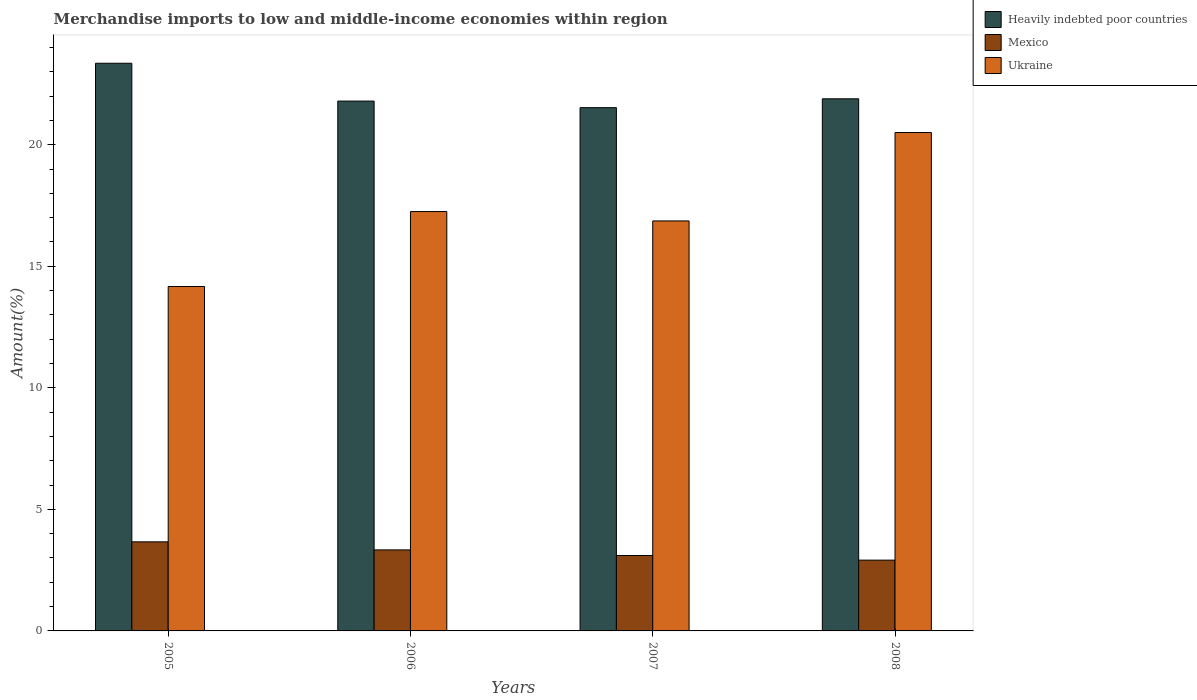How many groups of bars are there?
Provide a succinct answer. 4. Are the number of bars per tick equal to the number of legend labels?
Offer a terse response. Yes. How many bars are there on the 2nd tick from the left?
Your answer should be compact. 3. How many bars are there on the 4th tick from the right?
Keep it short and to the point. 3. In how many cases, is the number of bars for a given year not equal to the number of legend labels?
Your answer should be compact. 0. What is the percentage of amount earned from merchandise imports in Mexico in 2008?
Give a very brief answer. 2.91. Across all years, what is the maximum percentage of amount earned from merchandise imports in Heavily indebted poor countries?
Give a very brief answer. 23.35. Across all years, what is the minimum percentage of amount earned from merchandise imports in Heavily indebted poor countries?
Your response must be concise. 21.52. In which year was the percentage of amount earned from merchandise imports in Ukraine minimum?
Ensure brevity in your answer.  2005. What is the total percentage of amount earned from merchandise imports in Ukraine in the graph?
Provide a succinct answer. 68.78. What is the difference between the percentage of amount earned from merchandise imports in Mexico in 2005 and that in 2007?
Your response must be concise. 0.56. What is the difference between the percentage of amount earned from merchandise imports in Heavily indebted poor countries in 2007 and the percentage of amount earned from merchandise imports in Ukraine in 2005?
Provide a succinct answer. 7.36. What is the average percentage of amount earned from merchandise imports in Mexico per year?
Make the answer very short. 3.25. In the year 2007, what is the difference between the percentage of amount earned from merchandise imports in Ukraine and percentage of amount earned from merchandise imports in Mexico?
Provide a succinct answer. 13.76. In how many years, is the percentage of amount earned from merchandise imports in Heavily indebted poor countries greater than 21 %?
Provide a succinct answer. 4. What is the ratio of the percentage of amount earned from merchandise imports in Ukraine in 2006 to that in 2008?
Your answer should be compact. 0.84. What is the difference between the highest and the second highest percentage of amount earned from merchandise imports in Heavily indebted poor countries?
Your answer should be compact. 1.46. What is the difference between the highest and the lowest percentage of amount earned from merchandise imports in Heavily indebted poor countries?
Your answer should be compact. 1.83. What does the 1st bar from the left in 2007 represents?
Your answer should be very brief. Heavily indebted poor countries. What does the 3rd bar from the right in 2007 represents?
Keep it short and to the point. Heavily indebted poor countries. How many bars are there?
Ensure brevity in your answer.  12. How many years are there in the graph?
Your answer should be very brief. 4. What is the difference between two consecutive major ticks on the Y-axis?
Make the answer very short. 5. Are the values on the major ticks of Y-axis written in scientific E-notation?
Offer a very short reply. No. Does the graph contain any zero values?
Make the answer very short. No. Does the graph contain grids?
Your answer should be very brief. No. How many legend labels are there?
Give a very brief answer. 3. How are the legend labels stacked?
Make the answer very short. Vertical. What is the title of the graph?
Your answer should be compact. Merchandise imports to low and middle-income economies within region. Does "Luxembourg" appear as one of the legend labels in the graph?
Offer a terse response. No. What is the label or title of the X-axis?
Give a very brief answer. Years. What is the label or title of the Y-axis?
Keep it short and to the point. Amount(%). What is the Amount(%) of Heavily indebted poor countries in 2005?
Keep it short and to the point. 23.35. What is the Amount(%) of Mexico in 2005?
Offer a very short reply. 3.66. What is the Amount(%) in Ukraine in 2005?
Make the answer very short. 14.17. What is the Amount(%) in Heavily indebted poor countries in 2006?
Keep it short and to the point. 21.79. What is the Amount(%) in Mexico in 2006?
Offer a terse response. 3.33. What is the Amount(%) in Ukraine in 2006?
Give a very brief answer. 17.25. What is the Amount(%) of Heavily indebted poor countries in 2007?
Keep it short and to the point. 21.52. What is the Amount(%) in Mexico in 2007?
Give a very brief answer. 3.1. What is the Amount(%) of Ukraine in 2007?
Give a very brief answer. 16.86. What is the Amount(%) in Heavily indebted poor countries in 2008?
Your answer should be compact. 21.89. What is the Amount(%) of Mexico in 2008?
Your response must be concise. 2.91. What is the Amount(%) in Ukraine in 2008?
Offer a very short reply. 20.5. Across all years, what is the maximum Amount(%) in Heavily indebted poor countries?
Keep it short and to the point. 23.35. Across all years, what is the maximum Amount(%) of Mexico?
Give a very brief answer. 3.66. Across all years, what is the maximum Amount(%) of Ukraine?
Your answer should be very brief. 20.5. Across all years, what is the minimum Amount(%) of Heavily indebted poor countries?
Your response must be concise. 21.52. Across all years, what is the minimum Amount(%) in Mexico?
Provide a succinct answer. 2.91. Across all years, what is the minimum Amount(%) of Ukraine?
Keep it short and to the point. 14.17. What is the total Amount(%) in Heavily indebted poor countries in the graph?
Provide a short and direct response. 88.55. What is the total Amount(%) in Mexico in the graph?
Ensure brevity in your answer.  13.01. What is the total Amount(%) in Ukraine in the graph?
Ensure brevity in your answer.  68.78. What is the difference between the Amount(%) in Heavily indebted poor countries in 2005 and that in 2006?
Give a very brief answer. 1.56. What is the difference between the Amount(%) in Mexico in 2005 and that in 2006?
Your answer should be compact. 0.33. What is the difference between the Amount(%) of Ukraine in 2005 and that in 2006?
Make the answer very short. -3.08. What is the difference between the Amount(%) of Heavily indebted poor countries in 2005 and that in 2007?
Make the answer very short. 1.83. What is the difference between the Amount(%) of Mexico in 2005 and that in 2007?
Offer a terse response. 0.56. What is the difference between the Amount(%) in Ukraine in 2005 and that in 2007?
Your response must be concise. -2.7. What is the difference between the Amount(%) of Heavily indebted poor countries in 2005 and that in 2008?
Ensure brevity in your answer.  1.46. What is the difference between the Amount(%) in Mexico in 2005 and that in 2008?
Give a very brief answer. 0.75. What is the difference between the Amount(%) of Ukraine in 2005 and that in 2008?
Offer a terse response. -6.33. What is the difference between the Amount(%) of Heavily indebted poor countries in 2006 and that in 2007?
Provide a short and direct response. 0.27. What is the difference between the Amount(%) in Mexico in 2006 and that in 2007?
Keep it short and to the point. 0.23. What is the difference between the Amount(%) in Ukraine in 2006 and that in 2007?
Provide a short and direct response. 0.39. What is the difference between the Amount(%) of Heavily indebted poor countries in 2006 and that in 2008?
Offer a very short reply. -0.09. What is the difference between the Amount(%) in Mexico in 2006 and that in 2008?
Your response must be concise. 0.42. What is the difference between the Amount(%) in Ukraine in 2006 and that in 2008?
Your response must be concise. -3.25. What is the difference between the Amount(%) in Heavily indebted poor countries in 2007 and that in 2008?
Offer a terse response. -0.36. What is the difference between the Amount(%) in Mexico in 2007 and that in 2008?
Provide a short and direct response. 0.19. What is the difference between the Amount(%) of Ukraine in 2007 and that in 2008?
Your answer should be compact. -3.64. What is the difference between the Amount(%) in Heavily indebted poor countries in 2005 and the Amount(%) in Mexico in 2006?
Keep it short and to the point. 20.02. What is the difference between the Amount(%) of Heavily indebted poor countries in 2005 and the Amount(%) of Ukraine in 2006?
Offer a terse response. 6.1. What is the difference between the Amount(%) in Mexico in 2005 and the Amount(%) in Ukraine in 2006?
Offer a terse response. -13.59. What is the difference between the Amount(%) of Heavily indebted poor countries in 2005 and the Amount(%) of Mexico in 2007?
Provide a short and direct response. 20.25. What is the difference between the Amount(%) of Heavily indebted poor countries in 2005 and the Amount(%) of Ukraine in 2007?
Keep it short and to the point. 6.49. What is the difference between the Amount(%) of Mexico in 2005 and the Amount(%) of Ukraine in 2007?
Provide a succinct answer. -13.2. What is the difference between the Amount(%) in Heavily indebted poor countries in 2005 and the Amount(%) in Mexico in 2008?
Offer a very short reply. 20.44. What is the difference between the Amount(%) in Heavily indebted poor countries in 2005 and the Amount(%) in Ukraine in 2008?
Ensure brevity in your answer.  2.85. What is the difference between the Amount(%) in Mexico in 2005 and the Amount(%) in Ukraine in 2008?
Offer a terse response. -16.84. What is the difference between the Amount(%) of Heavily indebted poor countries in 2006 and the Amount(%) of Mexico in 2007?
Make the answer very short. 18.69. What is the difference between the Amount(%) in Heavily indebted poor countries in 2006 and the Amount(%) in Ukraine in 2007?
Keep it short and to the point. 4.93. What is the difference between the Amount(%) of Mexico in 2006 and the Amount(%) of Ukraine in 2007?
Make the answer very short. -13.53. What is the difference between the Amount(%) of Heavily indebted poor countries in 2006 and the Amount(%) of Mexico in 2008?
Ensure brevity in your answer.  18.88. What is the difference between the Amount(%) in Heavily indebted poor countries in 2006 and the Amount(%) in Ukraine in 2008?
Your answer should be very brief. 1.29. What is the difference between the Amount(%) in Mexico in 2006 and the Amount(%) in Ukraine in 2008?
Ensure brevity in your answer.  -17.17. What is the difference between the Amount(%) in Heavily indebted poor countries in 2007 and the Amount(%) in Mexico in 2008?
Ensure brevity in your answer.  18.61. What is the difference between the Amount(%) in Heavily indebted poor countries in 2007 and the Amount(%) in Ukraine in 2008?
Your answer should be very brief. 1.02. What is the difference between the Amount(%) of Mexico in 2007 and the Amount(%) of Ukraine in 2008?
Your answer should be compact. -17.4. What is the average Amount(%) in Heavily indebted poor countries per year?
Give a very brief answer. 22.14. What is the average Amount(%) in Mexico per year?
Give a very brief answer. 3.25. What is the average Amount(%) of Ukraine per year?
Give a very brief answer. 17.2. In the year 2005, what is the difference between the Amount(%) of Heavily indebted poor countries and Amount(%) of Mexico?
Your answer should be very brief. 19.69. In the year 2005, what is the difference between the Amount(%) in Heavily indebted poor countries and Amount(%) in Ukraine?
Your answer should be very brief. 9.18. In the year 2005, what is the difference between the Amount(%) of Mexico and Amount(%) of Ukraine?
Your response must be concise. -10.5. In the year 2006, what is the difference between the Amount(%) of Heavily indebted poor countries and Amount(%) of Mexico?
Ensure brevity in your answer.  18.46. In the year 2006, what is the difference between the Amount(%) in Heavily indebted poor countries and Amount(%) in Ukraine?
Ensure brevity in your answer.  4.54. In the year 2006, what is the difference between the Amount(%) of Mexico and Amount(%) of Ukraine?
Ensure brevity in your answer.  -13.92. In the year 2007, what is the difference between the Amount(%) in Heavily indebted poor countries and Amount(%) in Mexico?
Make the answer very short. 18.42. In the year 2007, what is the difference between the Amount(%) in Heavily indebted poor countries and Amount(%) in Ukraine?
Offer a very short reply. 4.66. In the year 2007, what is the difference between the Amount(%) of Mexico and Amount(%) of Ukraine?
Your answer should be very brief. -13.76. In the year 2008, what is the difference between the Amount(%) of Heavily indebted poor countries and Amount(%) of Mexico?
Offer a terse response. 18.98. In the year 2008, what is the difference between the Amount(%) in Heavily indebted poor countries and Amount(%) in Ukraine?
Offer a very short reply. 1.39. In the year 2008, what is the difference between the Amount(%) of Mexico and Amount(%) of Ukraine?
Provide a short and direct response. -17.59. What is the ratio of the Amount(%) of Heavily indebted poor countries in 2005 to that in 2006?
Your answer should be compact. 1.07. What is the ratio of the Amount(%) of Mexico in 2005 to that in 2006?
Give a very brief answer. 1.1. What is the ratio of the Amount(%) in Ukraine in 2005 to that in 2006?
Your answer should be very brief. 0.82. What is the ratio of the Amount(%) of Heavily indebted poor countries in 2005 to that in 2007?
Ensure brevity in your answer.  1.08. What is the ratio of the Amount(%) of Mexico in 2005 to that in 2007?
Keep it short and to the point. 1.18. What is the ratio of the Amount(%) of Ukraine in 2005 to that in 2007?
Your answer should be very brief. 0.84. What is the ratio of the Amount(%) in Heavily indebted poor countries in 2005 to that in 2008?
Give a very brief answer. 1.07. What is the ratio of the Amount(%) in Mexico in 2005 to that in 2008?
Offer a very short reply. 1.26. What is the ratio of the Amount(%) in Ukraine in 2005 to that in 2008?
Offer a terse response. 0.69. What is the ratio of the Amount(%) in Heavily indebted poor countries in 2006 to that in 2007?
Your answer should be compact. 1.01. What is the ratio of the Amount(%) of Mexico in 2006 to that in 2007?
Give a very brief answer. 1.07. What is the ratio of the Amount(%) of Ukraine in 2006 to that in 2007?
Provide a short and direct response. 1.02. What is the ratio of the Amount(%) of Mexico in 2006 to that in 2008?
Make the answer very short. 1.14. What is the ratio of the Amount(%) of Ukraine in 2006 to that in 2008?
Keep it short and to the point. 0.84. What is the ratio of the Amount(%) of Heavily indebted poor countries in 2007 to that in 2008?
Provide a short and direct response. 0.98. What is the ratio of the Amount(%) of Mexico in 2007 to that in 2008?
Make the answer very short. 1.07. What is the ratio of the Amount(%) in Ukraine in 2007 to that in 2008?
Provide a succinct answer. 0.82. What is the difference between the highest and the second highest Amount(%) in Heavily indebted poor countries?
Ensure brevity in your answer.  1.46. What is the difference between the highest and the second highest Amount(%) in Mexico?
Ensure brevity in your answer.  0.33. What is the difference between the highest and the second highest Amount(%) of Ukraine?
Make the answer very short. 3.25. What is the difference between the highest and the lowest Amount(%) of Heavily indebted poor countries?
Offer a terse response. 1.83. What is the difference between the highest and the lowest Amount(%) of Mexico?
Keep it short and to the point. 0.75. What is the difference between the highest and the lowest Amount(%) in Ukraine?
Ensure brevity in your answer.  6.33. 